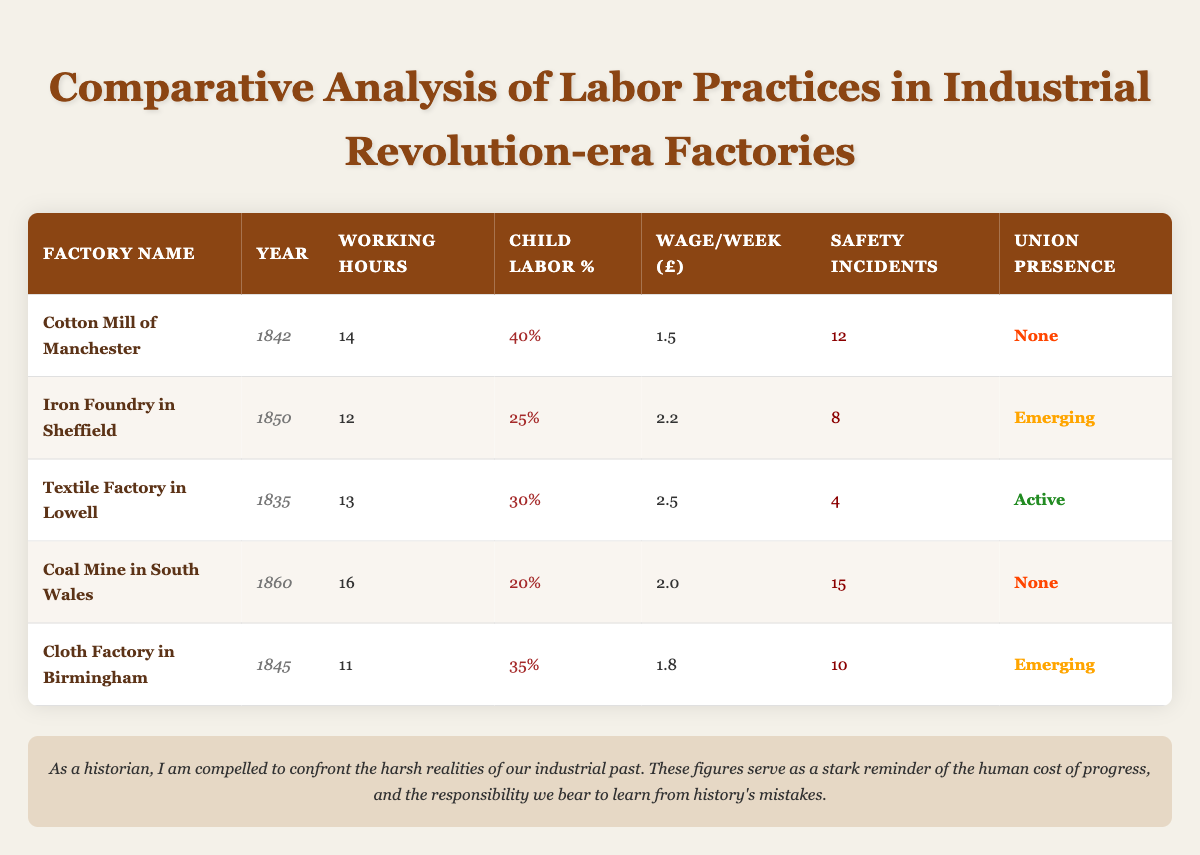What is the working hours of the Cotton Mill of Manchester? The working hours for the Cotton Mill of Manchester, as shown in the table, is listed in the row corresponding to that factory. It states 14 hours.
Answer: 14 What percentage of child labor was present in the Iron Foundry in Sheffield? The table provides the child labor percentage for the Iron Foundry in Sheffield in its respective row, which is 25%.
Answer: 25% Which factory has the highest number of safety incidents? To determine the factory with the most safety incidents, we compare the numbers from all factories listed in the table. The Coal Mine in South Wales has 15 incidents, which is the highest.
Answer: Coal Mine in South Wales Is there any factory that had an active union presence? By examining the 'Union Presence' column, we see that the Textile Factory in Lowell is the only factory marked as having 'Active' union presence.
Answer: Yes What is the average wage per week for factories that have emerging union presence? We identify the factories with emerging union presence, which are the Iron Foundry in Sheffield and the Cloth Factory in Birmingham. The wages are 2.2 and 1.8 respectively. To find the average, we add these two values (2.2 + 1.8 = 4.0) and divide by 2 (4.0 / 2 = 2.0).
Answer: 2.0 Which factory had the lowest working hours, and what was that duration? We evaluate the 'Working Hours' column to identify the lowest value. The Cloth Factory in Birmingham has the lowest duration listed at 11 hours.
Answer: Cloth Factory in Birmingham, 11 hours What is the total number of safety incidents reported in all factories? We sum the safety incidents across all factories: 12 + 8 + 4 + 15 + 10 = 49. This gives us the total number of safety incidents reported.
Answer: 49 Did any factory report child labor above 35%? We check the 'Child Labor %' column to see if any values exceed 35%. The Cotton Mill of Manchester reported 40%, which is above that threshold.
Answer: Yes What is the median number of working hours across all factories? To find the median working hours, we first list the working hours in ascending order: 11, 12, 13, 14, 16. The median is the middle value of this list, which in this case is the third value, 13 hours.
Answer: 13 Which factory had the highest child labor percentage, and what was that percentage? Reviewing the 'Child Labor %' column, the Cotton Mill of Manchester has the highest percentage at 40%.
Answer: Cotton Mill of Manchester, 40% 